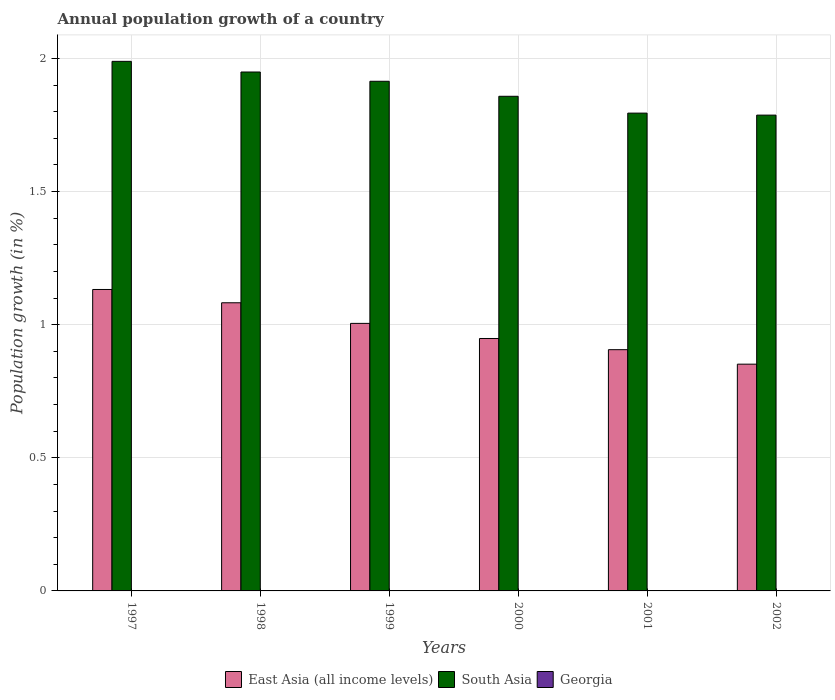How many groups of bars are there?
Offer a very short reply. 6. Are the number of bars per tick equal to the number of legend labels?
Offer a very short reply. No. Are the number of bars on each tick of the X-axis equal?
Your answer should be compact. Yes. How many bars are there on the 4th tick from the left?
Make the answer very short. 2. How many bars are there on the 6th tick from the right?
Offer a very short reply. 2. What is the label of the 3rd group of bars from the left?
Offer a very short reply. 1999. In how many cases, is the number of bars for a given year not equal to the number of legend labels?
Provide a succinct answer. 6. What is the annual population growth in East Asia (all income levels) in 1999?
Your answer should be compact. 1. Across all years, what is the maximum annual population growth in East Asia (all income levels)?
Provide a short and direct response. 1.13. Across all years, what is the minimum annual population growth in East Asia (all income levels)?
Provide a succinct answer. 0.85. In which year was the annual population growth in South Asia maximum?
Offer a very short reply. 1997. What is the total annual population growth in Georgia in the graph?
Keep it short and to the point. 0. What is the difference between the annual population growth in South Asia in 1998 and that in 1999?
Offer a very short reply. 0.03. What is the difference between the annual population growth in East Asia (all income levels) in 1997 and the annual population growth in Georgia in 2002?
Give a very brief answer. 1.13. In the year 1997, what is the difference between the annual population growth in East Asia (all income levels) and annual population growth in South Asia?
Your answer should be very brief. -0.86. In how many years, is the annual population growth in East Asia (all income levels) greater than 0.1 %?
Offer a very short reply. 6. What is the ratio of the annual population growth in East Asia (all income levels) in 2000 to that in 2002?
Keep it short and to the point. 1.11. Is the difference between the annual population growth in East Asia (all income levels) in 1997 and 2002 greater than the difference between the annual population growth in South Asia in 1997 and 2002?
Your answer should be compact. Yes. What is the difference between the highest and the second highest annual population growth in East Asia (all income levels)?
Ensure brevity in your answer.  0.05. What is the difference between the highest and the lowest annual population growth in East Asia (all income levels)?
Offer a terse response. 0.28. Is the sum of the annual population growth in South Asia in 1997 and 1999 greater than the maximum annual population growth in Georgia across all years?
Your answer should be very brief. Yes. Are all the bars in the graph horizontal?
Provide a succinct answer. No. How many years are there in the graph?
Provide a succinct answer. 6. What is the difference between two consecutive major ticks on the Y-axis?
Your answer should be compact. 0.5. Are the values on the major ticks of Y-axis written in scientific E-notation?
Keep it short and to the point. No. Does the graph contain any zero values?
Provide a succinct answer. Yes. Does the graph contain grids?
Provide a succinct answer. Yes. Where does the legend appear in the graph?
Your answer should be compact. Bottom center. How are the legend labels stacked?
Your answer should be very brief. Horizontal. What is the title of the graph?
Make the answer very short. Annual population growth of a country. What is the label or title of the X-axis?
Make the answer very short. Years. What is the label or title of the Y-axis?
Offer a terse response. Population growth (in %). What is the Population growth (in %) of East Asia (all income levels) in 1997?
Your response must be concise. 1.13. What is the Population growth (in %) in South Asia in 1997?
Give a very brief answer. 1.99. What is the Population growth (in %) of Georgia in 1997?
Give a very brief answer. 0. What is the Population growth (in %) of East Asia (all income levels) in 1998?
Keep it short and to the point. 1.08. What is the Population growth (in %) of South Asia in 1998?
Ensure brevity in your answer.  1.95. What is the Population growth (in %) in East Asia (all income levels) in 1999?
Your answer should be very brief. 1. What is the Population growth (in %) of South Asia in 1999?
Ensure brevity in your answer.  1.91. What is the Population growth (in %) in Georgia in 1999?
Your response must be concise. 0. What is the Population growth (in %) of East Asia (all income levels) in 2000?
Ensure brevity in your answer.  0.95. What is the Population growth (in %) in South Asia in 2000?
Offer a very short reply. 1.86. What is the Population growth (in %) of Georgia in 2000?
Your response must be concise. 0. What is the Population growth (in %) of East Asia (all income levels) in 2001?
Your answer should be very brief. 0.91. What is the Population growth (in %) of South Asia in 2001?
Offer a terse response. 1.79. What is the Population growth (in %) of Georgia in 2001?
Offer a very short reply. 0. What is the Population growth (in %) of East Asia (all income levels) in 2002?
Your answer should be compact. 0.85. What is the Population growth (in %) of South Asia in 2002?
Provide a succinct answer. 1.79. What is the Population growth (in %) in Georgia in 2002?
Provide a succinct answer. 0. Across all years, what is the maximum Population growth (in %) in East Asia (all income levels)?
Give a very brief answer. 1.13. Across all years, what is the maximum Population growth (in %) in South Asia?
Ensure brevity in your answer.  1.99. Across all years, what is the minimum Population growth (in %) in East Asia (all income levels)?
Provide a short and direct response. 0.85. Across all years, what is the minimum Population growth (in %) of South Asia?
Give a very brief answer. 1.79. What is the total Population growth (in %) of East Asia (all income levels) in the graph?
Your answer should be very brief. 5.93. What is the total Population growth (in %) in South Asia in the graph?
Your answer should be very brief. 11.29. What is the difference between the Population growth (in %) of East Asia (all income levels) in 1997 and that in 1998?
Give a very brief answer. 0.05. What is the difference between the Population growth (in %) in South Asia in 1997 and that in 1998?
Keep it short and to the point. 0.04. What is the difference between the Population growth (in %) in East Asia (all income levels) in 1997 and that in 1999?
Offer a terse response. 0.13. What is the difference between the Population growth (in %) in South Asia in 1997 and that in 1999?
Provide a short and direct response. 0.07. What is the difference between the Population growth (in %) of East Asia (all income levels) in 1997 and that in 2000?
Your answer should be very brief. 0.18. What is the difference between the Population growth (in %) in South Asia in 1997 and that in 2000?
Your response must be concise. 0.13. What is the difference between the Population growth (in %) in East Asia (all income levels) in 1997 and that in 2001?
Your response must be concise. 0.23. What is the difference between the Population growth (in %) in South Asia in 1997 and that in 2001?
Provide a succinct answer. 0.19. What is the difference between the Population growth (in %) of East Asia (all income levels) in 1997 and that in 2002?
Offer a very short reply. 0.28. What is the difference between the Population growth (in %) of South Asia in 1997 and that in 2002?
Offer a terse response. 0.2. What is the difference between the Population growth (in %) in East Asia (all income levels) in 1998 and that in 1999?
Keep it short and to the point. 0.08. What is the difference between the Population growth (in %) of South Asia in 1998 and that in 1999?
Ensure brevity in your answer.  0.03. What is the difference between the Population growth (in %) in East Asia (all income levels) in 1998 and that in 2000?
Keep it short and to the point. 0.13. What is the difference between the Population growth (in %) in South Asia in 1998 and that in 2000?
Keep it short and to the point. 0.09. What is the difference between the Population growth (in %) in East Asia (all income levels) in 1998 and that in 2001?
Offer a terse response. 0.18. What is the difference between the Population growth (in %) of South Asia in 1998 and that in 2001?
Keep it short and to the point. 0.15. What is the difference between the Population growth (in %) of East Asia (all income levels) in 1998 and that in 2002?
Provide a short and direct response. 0.23. What is the difference between the Population growth (in %) of South Asia in 1998 and that in 2002?
Your response must be concise. 0.16. What is the difference between the Population growth (in %) in East Asia (all income levels) in 1999 and that in 2000?
Offer a terse response. 0.06. What is the difference between the Population growth (in %) in South Asia in 1999 and that in 2000?
Your answer should be very brief. 0.06. What is the difference between the Population growth (in %) of East Asia (all income levels) in 1999 and that in 2001?
Provide a short and direct response. 0.1. What is the difference between the Population growth (in %) of South Asia in 1999 and that in 2001?
Offer a terse response. 0.12. What is the difference between the Population growth (in %) in East Asia (all income levels) in 1999 and that in 2002?
Offer a terse response. 0.15. What is the difference between the Population growth (in %) in South Asia in 1999 and that in 2002?
Ensure brevity in your answer.  0.13. What is the difference between the Population growth (in %) of East Asia (all income levels) in 2000 and that in 2001?
Your response must be concise. 0.04. What is the difference between the Population growth (in %) of South Asia in 2000 and that in 2001?
Your answer should be very brief. 0.06. What is the difference between the Population growth (in %) of East Asia (all income levels) in 2000 and that in 2002?
Provide a succinct answer. 0.1. What is the difference between the Population growth (in %) in South Asia in 2000 and that in 2002?
Provide a short and direct response. 0.07. What is the difference between the Population growth (in %) in East Asia (all income levels) in 2001 and that in 2002?
Make the answer very short. 0.05. What is the difference between the Population growth (in %) of South Asia in 2001 and that in 2002?
Make the answer very short. 0.01. What is the difference between the Population growth (in %) of East Asia (all income levels) in 1997 and the Population growth (in %) of South Asia in 1998?
Offer a very short reply. -0.82. What is the difference between the Population growth (in %) of East Asia (all income levels) in 1997 and the Population growth (in %) of South Asia in 1999?
Provide a short and direct response. -0.78. What is the difference between the Population growth (in %) in East Asia (all income levels) in 1997 and the Population growth (in %) in South Asia in 2000?
Make the answer very short. -0.73. What is the difference between the Population growth (in %) of East Asia (all income levels) in 1997 and the Population growth (in %) of South Asia in 2001?
Your answer should be very brief. -0.66. What is the difference between the Population growth (in %) in East Asia (all income levels) in 1997 and the Population growth (in %) in South Asia in 2002?
Ensure brevity in your answer.  -0.65. What is the difference between the Population growth (in %) in East Asia (all income levels) in 1998 and the Population growth (in %) in South Asia in 1999?
Ensure brevity in your answer.  -0.83. What is the difference between the Population growth (in %) of East Asia (all income levels) in 1998 and the Population growth (in %) of South Asia in 2000?
Your answer should be compact. -0.78. What is the difference between the Population growth (in %) in East Asia (all income levels) in 1998 and the Population growth (in %) in South Asia in 2001?
Your answer should be compact. -0.71. What is the difference between the Population growth (in %) of East Asia (all income levels) in 1998 and the Population growth (in %) of South Asia in 2002?
Provide a short and direct response. -0.7. What is the difference between the Population growth (in %) of East Asia (all income levels) in 1999 and the Population growth (in %) of South Asia in 2000?
Make the answer very short. -0.85. What is the difference between the Population growth (in %) of East Asia (all income levels) in 1999 and the Population growth (in %) of South Asia in 2001?
Keep it short and to the point. -0.79. What is the difference between the Population growth (in %) of East Asia (all income levels) in 1999 and the Population growth (in %) of South Asia in 2002?
Your answer should be compact. -0.78. What is the difference between the Population growth (in %) of East Asia (all income levels) in 2000 and the Population growth (in %) of South Asia in 2001?
Provide a short and direct response. -0.85. What is the difference between the Population growth (in %) in East Asia (all income levels) in 2000 and the Population growth (in %) in South Asia in 2002?
Keep it short and to the point. -0.84. What is the difference between the Population growth (in %) of East Asia (all income levels) in 2001 and the Population growth (in %) of South Asia in 2002?
Make the answer very short. -0.88. What is the average Population growth (in %) of East Asia (all income levels) per year?
Provide a succinct answer. 0.99. What is the average Population growth (in %) of South Asia per year?
Your answer should be compact. 1.88. In the year 1997, what is the difference between the Population growth (in %) of East Asia (all income levels) and Population growth (in %) of South Asia?
Offer a very short reply. -0.86. In the year 1998, what is the difference between the Population growth (in %) of East Asia (all income levels) and Population growth (in %) of South Asia?
Your answer should be very brief. -0.87. In the year 1999, what is the difference between the Population growth (in %) of East Asia (all income levels) and Population growth (in %) of South Asia?
Your answer should be very brief. -0.91. In the year 2000, what is the difference between the Population growth (in %) in East Asia (all income levels) and Population growth (in %) in South Asia?
Ensure brevity in your answer.  -0.91. In the year 2001, what is the difference between the Population growth (in %) of East Asia (all income levels) and Population growth (in %) of South Asia?
Your answer should be compact. -0.89. In the year 2002, what is the difference between the Population growth (in %) of East Asia (all income levels) and Population growth (in %) of South Asia?
Provide a succinct answer. -0.94. What is the ratio of the Population growth (in %) of East Asia (all income levels) in 1997 to that in 1998?
Provide a succinct answer. 1.05. What is the ratio of the Population growth (in %) of South Asia in 1997 to that in 1998?
Make the answer very short. 1.02. What is the ratio of the Population growth (in %) in East Asia (all income levels) in 1997 to that in 1999?
Make the answer very short. 1.13. What is the ratio of the Population growth (in %) of South Asia in 1997 to that in 1999?
Your answer should be very brief. 1.04. What is the ratio of the Population growth (in %) in East Asia (all income levels) in 1997 to that in 2000?
Offer a very short reply. 1.19. What is the ratio of the Population growth (in %) of South Asia in 1997 to that in 2000?
Ensure brevity in your answer.  1.07. What is the ratio of the Population growth (in %) in East Asia (all income levels) in 1997 to that in 2001?
Offer a terse response. 1.25. What is the ratio of the Population growth (in %) in South Asia in 1997 to that in 2001?
Provide a short and direct response. 1.11. What is the ratio of the Population growth (in %) of East Asia (all income levels) in 1997 to that in 2002?
Keep it short and to the point. 1.33. What is the ratio of the Population growth (in %) of South Asia in 1997 to that in 2002?
Your response must be concise. 1.11. What is the ratio of the Population growth (in %) of East Asia (all income levels) in 1998 to that in 1999?
Offer a terse response. 1.08. What is the ratio of the Population growth (in %) of South Asia in 1998 to that in 1999?
Make the answer very short. 1.02. What is the ratio of the Population growth (in %) in East Asia (all income levels) in 1998 to that in 2000?
Provide a short and direct response. 1.14. What is the ratio of the Population growth (in %) of South Asia in 1998 to that in 2000?
Your answer should be compact. 1.05. What is the ratio of the Population growth (in %) of East Asia (all income levels) in 1998 to that in 2001?
Your answer should be compact. 1.19. What is the ratio of the Population growth (in %) in South Asia in 1998 to that in 2001?
Your answer should be very brief. 1.09. What is the ratio of the Population growth (in %) of East Asia (all income levels) in 1998 to that in 2002?
Give a very brief answer. 1.27. What is the ratio of the Population growth (in %) of South Asia in 1998 to that in 2002?
Your response must be concise. 1.09. What is the ratio of the Population growth (in %) in East Asia (all income levels) in 1999 to that in 2000?
Ensure brevity in your answer.  1.06. What is the ratio of the Population growth (in %) in South Asia in 1999 to that in 2000?
Your answer should be very brief. 1.03. What is the ratio of the Population growth (in %) in East Asia (all income levels) in 1999 to that in 2001?
Your answer should be compact. 1.11. What is the ratio of the Population growth (in %) in South Asia in 1999 to that in 2001?
Your response must be concise. 1.07. What is the ratio of the Population growth (in %) of East Asia (all income levels) in 1999 to that in 2002?
Your answer should be very brief. 1.18. What is the ratio of the Population growth (in %) in South Asia in 1999 to that in 2002?
Ensure brevity in your answer.  1.07. What is the ratio of the Population growth (in %) of East Asia (all income levels) in 2000 to that in 2001?
Your answer should be compact. 1.05. What is the ratio of the Population growth (in %) in South Asia in 2000 to that in 2001?
Keep it short and to the point. 1.04. What is the ratio of the Population growth (in %) of East Asia (all income levels) in 2000 to that in 2002?
Offer a very short reply. 1.11. What is the ratio of the Population growth (in %) of South Asia in 2000 to that in 2002?
Your response must be concise. 1.04. What is the ratio of the Population growth (in %) of East Asia (all income levels) in 2001 to that in 2002?
Offer a terse response. 1.06. What is the ratio of the Population growth (in %) in South Asia in 2001 to that in 2002?
Your response must be concise. 1. What is the difference between the highest and the second highest Population growth (in %) of East Asia (all income levels)?
Offer a very short reply. 0.05. What is the difference between the highest and the lowest Population growth (in %) of East Asia (all income levels)?
Offer a terse response. 0.28. What is the difference between the highest and the lowest Population growth (in %) of South Asia?
Give a very brief answer. 0.2. 